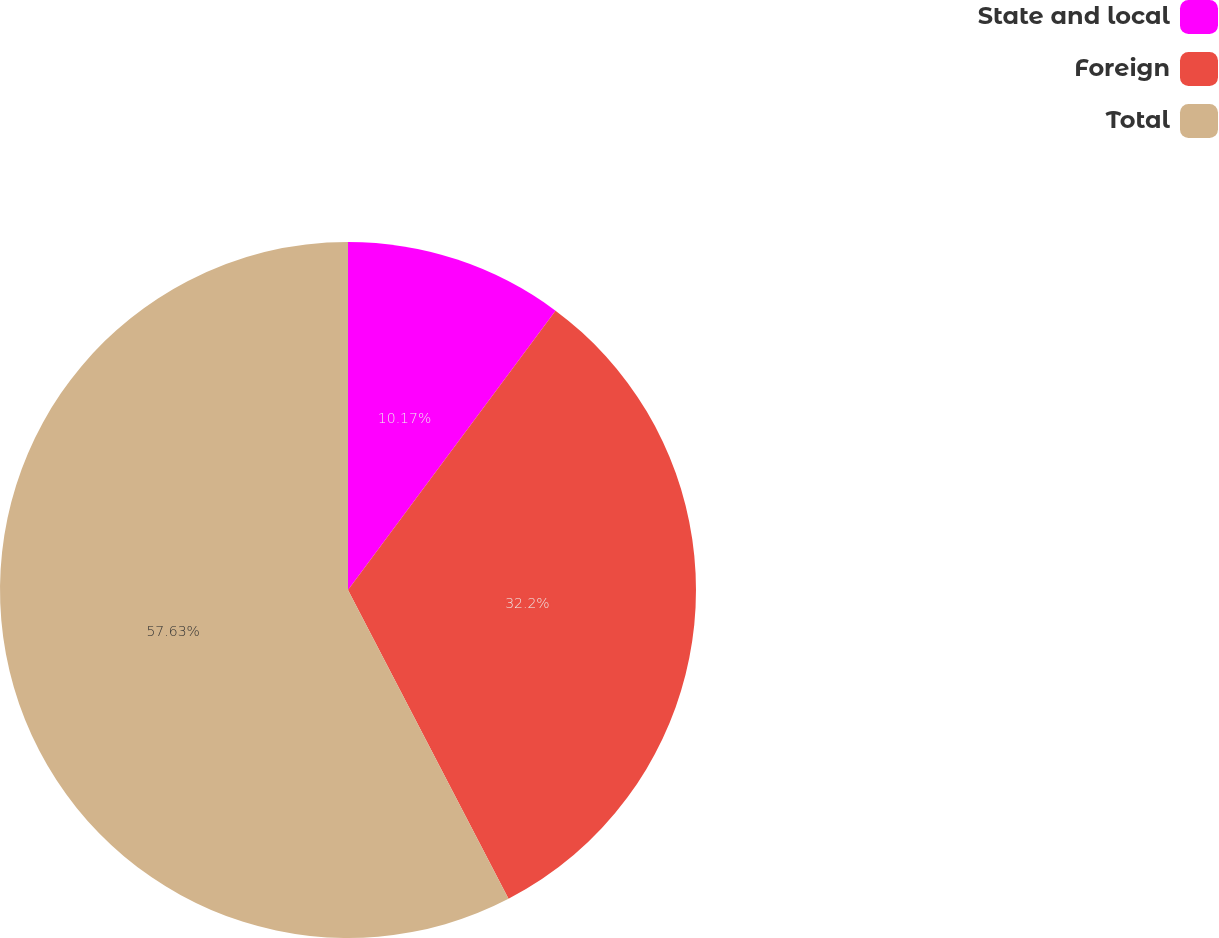<chart> <loc_0><loc_0><loc_500><loc_500><pie_chart><fcel>State and local<fcel>Foreign<fcel>Total<nl><fcel>10.17%<fcel>32.2%<fcel>57.63%<nl></chart> 